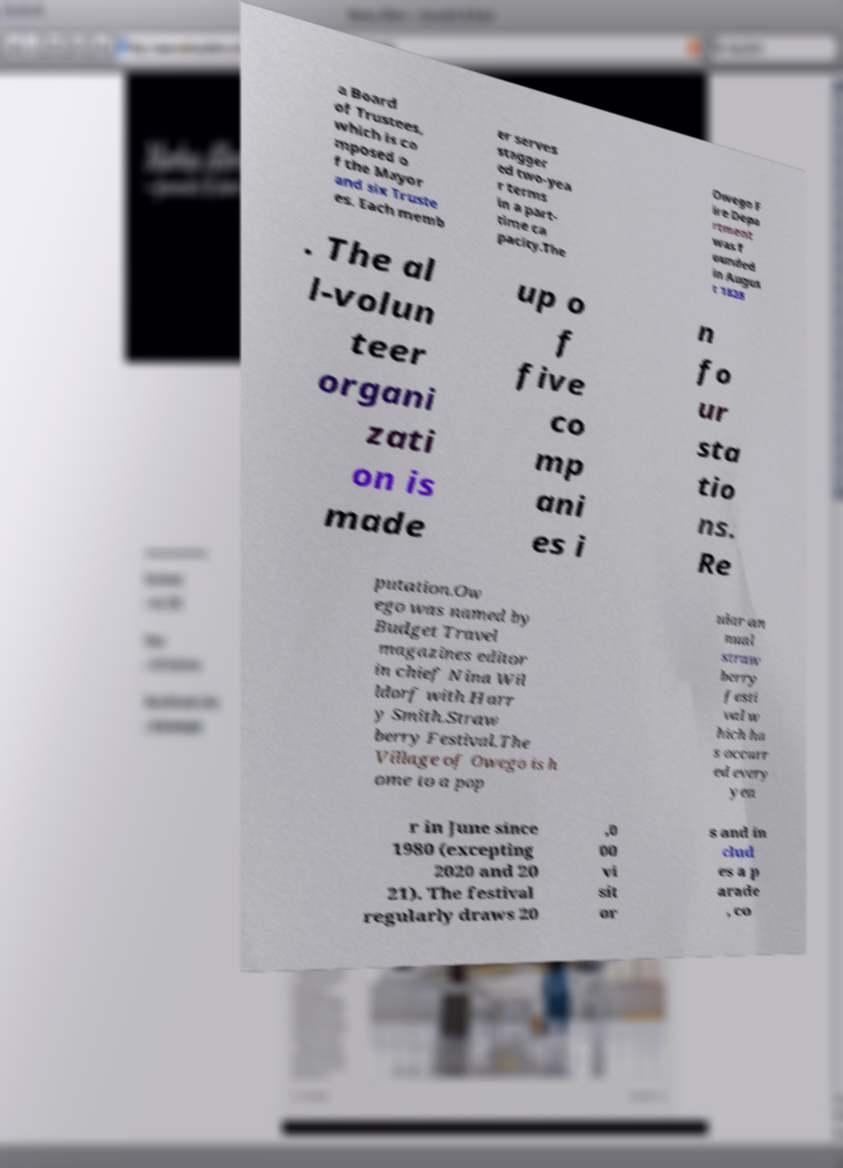I need the written content from this picture converted into text. Can you do that? a Board of Trustees, which is co mposed o f the Mayor and six Truste es. Each memb er serves stagger ed two-yea r terms in a part- time ca pacity.The Owego F ire Depa rtment was f ounded in Augus t 1828 . The al l-volun teer organi zati on is made up o f five co mp ani es i n fo ur sta tio ns. Re putation.Ow ego was named by Budget Travel magazines editor in chief Nina Wil ldorf with Harr y Smith.Straw berry Festival.The Village of Owego is h ome to a pop ular an nual straw berry festi val w hich ha s occurr ed every yea r in June since 1980 (excepting 2020 and 20 21). The festival regularly draws 20 ,0 00 vi sit or s and in clud es a p arade , co 